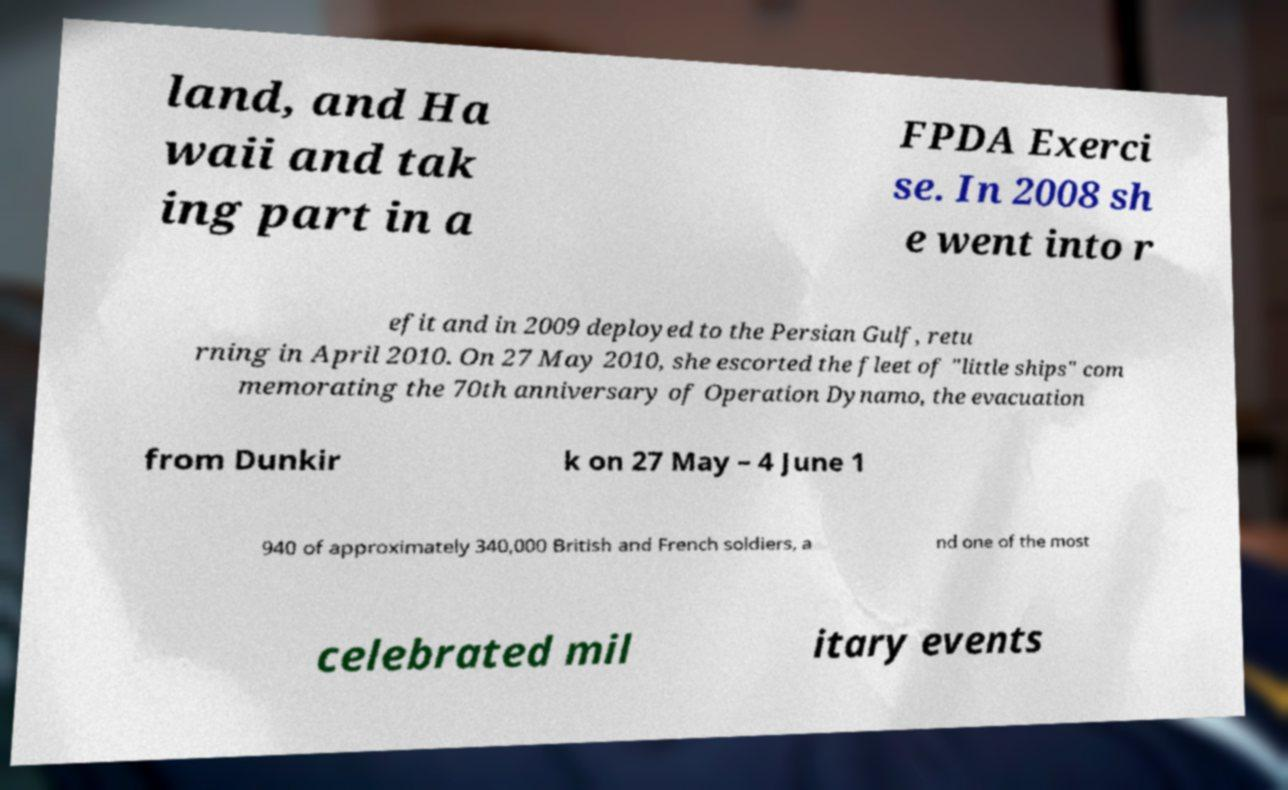There's text embedded in this image that I need extracted. Can you transcribe it verbatim? land, and Ha waii and tak ing part in a FPDA Exerci se. In 2008 sh e went into r efit and in 2009 deployed to the Persian Gulf, retu rning in April 2010. On 27 May 2010, she escorted the fleet of "little ships" com memorating the 70th anniversary of Operation Dynamo, the evacuation from Dunkir k on 27 May – 4 June 1 940 of approximately 340,000 British and French soldiers, a nd one of the most celebrated mil itary events 